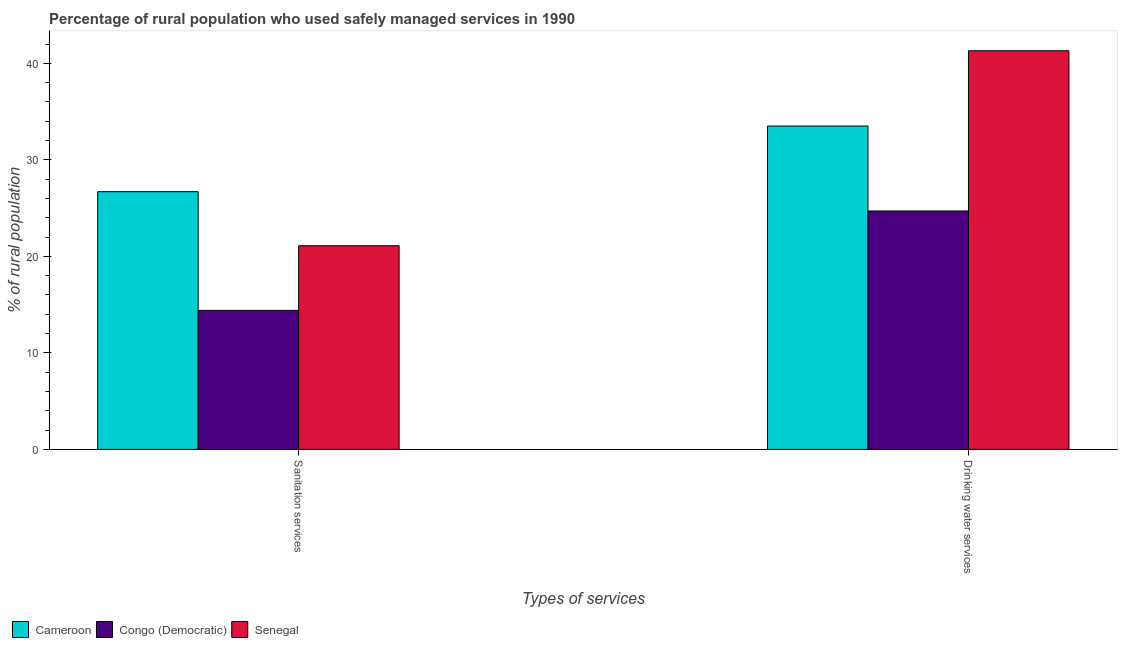How many groups of bars are there?
Offer a terse response. 2. Are the number of bars per tick equal to the number of legend labels?
Your answer should be compact. Yes. Are the number of bars on each tick of the X-axis equal?
Your response must be concise. Yes. What is the label of the 1st group of bars from the left?
Ensure brevity in your answer.  Sanitation services. What is the percentage of rural population who used sanitation services in Cameroon?
Offer a very short reply. 26.7. Across all countries, what is the maximum percentage of rural population who used sanitation services?
Your response must be concise. 26.7. Across all countries, what is the minimum percentage of rural population who used drinking water services?
Make the answer very short. 24.7. In which country was the percentage of rural population who used drinking water services maximum?
Your answer should be very brief. Senegal. In which country was the percentage of rural population who used drinking water services minimum?
Your answer should be very brief. Congo (Democratic). What is the total percentage of rural population who used drinking water services in the graph?
Provide a succinct answer. 99.5. What is the difference between the percentage of rural population who used drinking water services in Cameroon and that in Senegal?
Give a very brief answer. -7.8. What is the difference between the percentage of rural population who used drinking water services in Congo (Democratic) and the percentage of rural population who used sanitation services in Senegal?
Provide a succinct answer. 3.6. What is the average percentage of rural population who used sanitation services per country?
Make the answer very short. 20.73. What is the difference between the percentage of rural population who used sanitation services and percentage of rural population who used drinking water services in Congo (Democratic)?
Make the answer very short. -10.3. What is the ratio of the percentage of rural population who used drinking water services in Senegal to that in Cameroon?
Give a very brief answer. 1.23. Is the percentage of rural population who used sanitation services in Senegal less than that in Congo (Democratic)?
Your response must be concise. No. In how many countries, is the percentage of rural population who used sanitation services greater than the average percentage of rural population who used sanitation services taken over all countries?
Provide a succinct answer. 2. What does the 1st bar from the left in Drinking water services represents?
Your answer should be very brief. Cameroon. What does the 3rd bar from the right in Drinking water services represents?
Provide a short and direct response. Cameroon. How many bars are there?
Your response must be concise. 6. Are the values on the major ticks of Y-axis written in scientific E-notation?
Your answer should be compact. No. Does the graph contain any zero values?
Offer a very short reply. No. Does the graph contain grids?
Ensure brevity in your answer.  No. Where does the legend appear in the graph?
Offer a very short reply. Bottom left. How many legend labels are there?
Make the answer very short. 3. What is the title of the graph?
Offer a very short reply. Percentage of rural population who used safely managed services in 1990. Does "Cuba" appear as one of the legend labels in the graph?
Your answer should be very brief. No. What is the label or title of the X-axis?
Ensure brevity in your answer.  Types of services. What is the label or title of the Y-axis?
Give a very brief answer. % of rural population. What is the % of rural population of Cameroon in Sanitation services?
Offer a terse response. 26.7. What is the % of rural population of Congo (Democratic) in Sanitation services?
Make the answer very short. 14.4. What is the % of rural population of Senegal in Sanitation services?
Your response must be concise. 21.1. What is the % of rural population in Cameroon in Drinking water services?
Give a very brief answer. 33.5. What is the % of rural population in Congo (Democratic) in Drinking water services?
Your response must be concise. 24.7. What is the % of rural population in Senegal in Drinking water services?
Offer a terse response. 41.3. Across all Types of services, what is the maximum % of rural population of Cameroon?
Ensure brevity in your answer.  33.5. Across all Types of services, what is the maximum % of rural population in Congo (Democratic)?
Keep it short and to the point. 24.7. Across all Types of services, what is the maximum % of rural population of Senegal?
Make the answer very short. 41.3. Across all Types of services, what is the minimum % of rural population in Cameroon?
Your answer should be compact. 26.7. Across all Types of services, what is the minimum % of rural population of Congo (Democratic)?
Keep it short and to the point. 14.4. Across all Types of services, what is the minimum % of rural population of Senegal?
Ensure brevity in your answer.  21.1. What is the total % of rural population in Cameroon in the graph?
Your answer should be compact. 60.2. What is the total % of rural population in Congo (Democratic) in the graph?
Your answer should be very brief. 39.1. What is the total % of rural population in Senegal in the graph?
Your response must be concise. 62.4. What is the difference between the % of rural population of Congo (Democratic) in Sanitation services and that in Drinking water services?
Give a very brief answer. -10.3. What is the difference between the % of rural population in Senegal in Sanitation services and that in Drinking water services?
Keep it short and to the point. -20.2. What is the difference between the % of rural population in Cameroon in Sanitation services and the % of rural population in Congo (Democratic) in Drinking water services?
Provide a succinct answer. 2. What is the difference between the % of rural population of Cameroon in Sanitation services and the % of rural population of Senegal in Drinking water services?
Provide a short and direct response. -14.6. What is the difference between the % of rural population in Congo (Democratic) in Sanitation services and the % of rural population in Senegal in Drinking water services?
Your response must be concise. -26.9. What is the average % of rural population in Cameroon per Types of services?
Offer a very short reply. 30.1. What is the average % of rural population in Congo (Democratic) per Types of services?
Keep it short and to the point. 19.55. What is the average % of rural population in Senegal per Types of services?
Give a very brief answer. 31.2. What is the difference between the % of rural population of Congo (Democratic) and % of rural population of Senegal in Sanitation services?
Provide a short and direct response. -6.7. What is the difference between the % of rural population of Cameroon and % of rural population of Senegal in Drinking water services?
Your answer should be compact. -7.8. What is the difference between the % of rural population in Congo (Democratic) and % of rural population in Senegal in Drinking water services?
Ensure brevity in your answer.  -16.6. What is the ratio of the % of rural population in Cameroon in Sanitation services to that in Drinking water services?
Offer a very short reply. 0.8. What is the ratio of the % of rural population in Congo (Democratic) in Sanitation services to that in Drinking water services?
Provide a short and direct response. 0.58. What is the ratio of the % of rural population of Senegal in Sanitation services to that in Drinking water services?
Offer a very short reply. 0.51. What is the difference between the highest and the second highest % of rural population in Cameroon?
Provide a succinct answer. 6.8. What is the difference between the highest and the second highest % of rural population in Congo (Democratic)?
Provide a short and direct response. 10.3. What is the difference between the highest and the second highest % of rural population in Senegal?
Ensure brevity in your answer.  20.2. What is the difference between the highest and the lowest % of rural population in Senegal?
Make the answer very short. 20.2. 